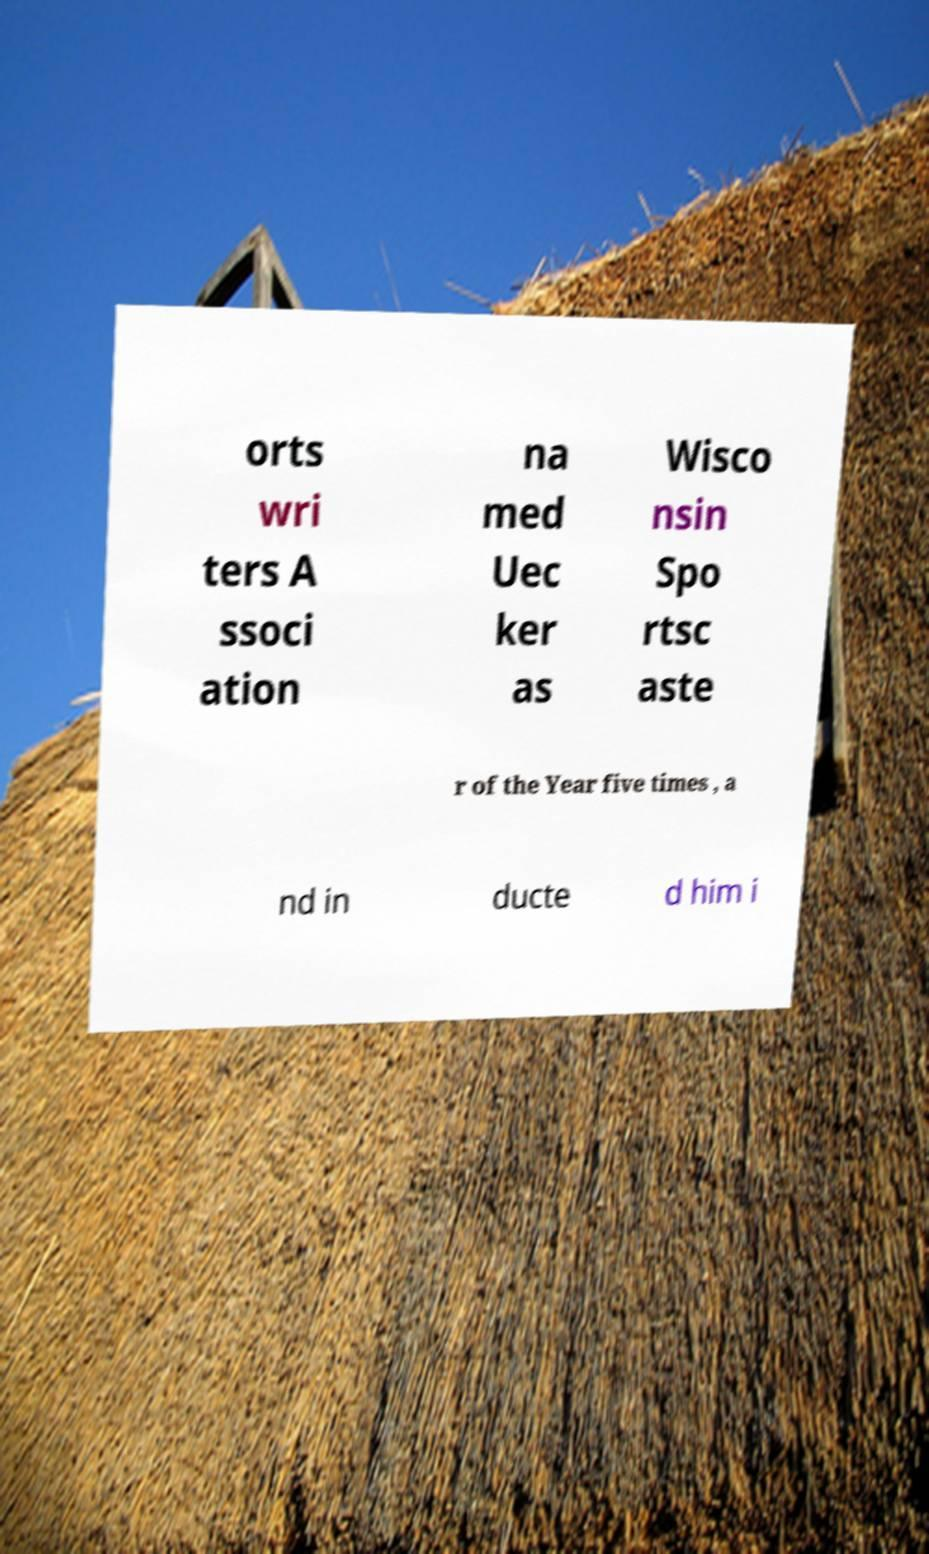Can you read and provide the text displayed in the image?This photo seems to have some interesting text. Can you extract and type it out for me? orts wri ters A ssoci ation na med Uec ker as Wisco nsin Spo rtsc aste r of the Year five times , a nd in ducte d him i 